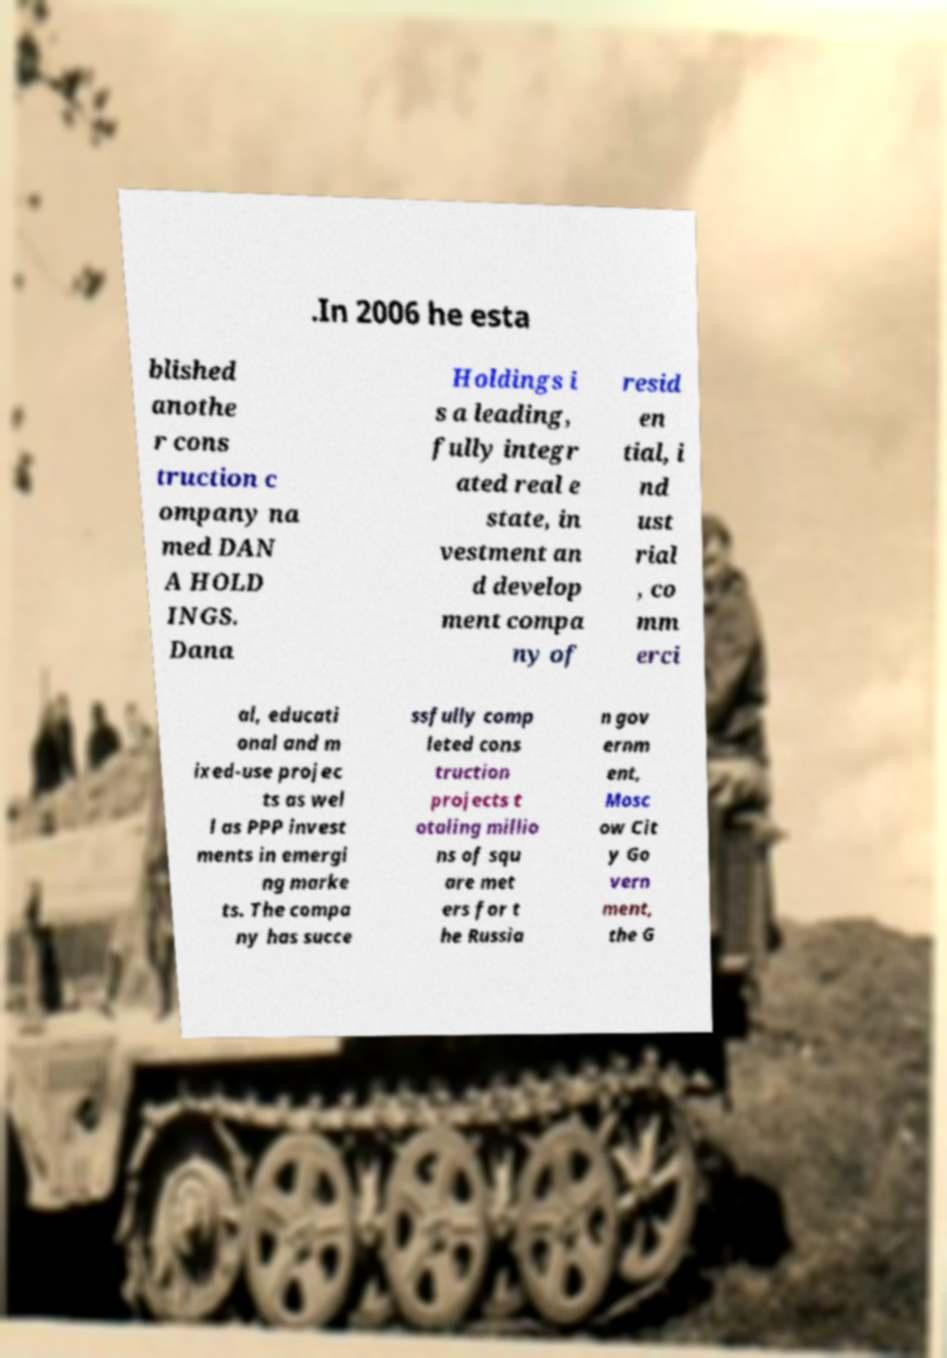Can you accurately transcribe the text from the provided image for me? .In 2006 he esta blished anothe r cons truction c ompany na med DAN A HOLD INGS. Dana Holdings i s a leading, fully integr ated real e state, in vestment an d develop ment compa ny of resid en tial, i nd ust rial , co mm erci al, educati onal and m ixed-use projec ts as wel l as PPP invest ments in emergi ng marke ts. The compa ny has succe ssfully comp leted cons truction projects t otaling millio ns of squ are met ers for t he Russia n gov ernm ent, Mosc ow Cit y Go vern ment, the G 